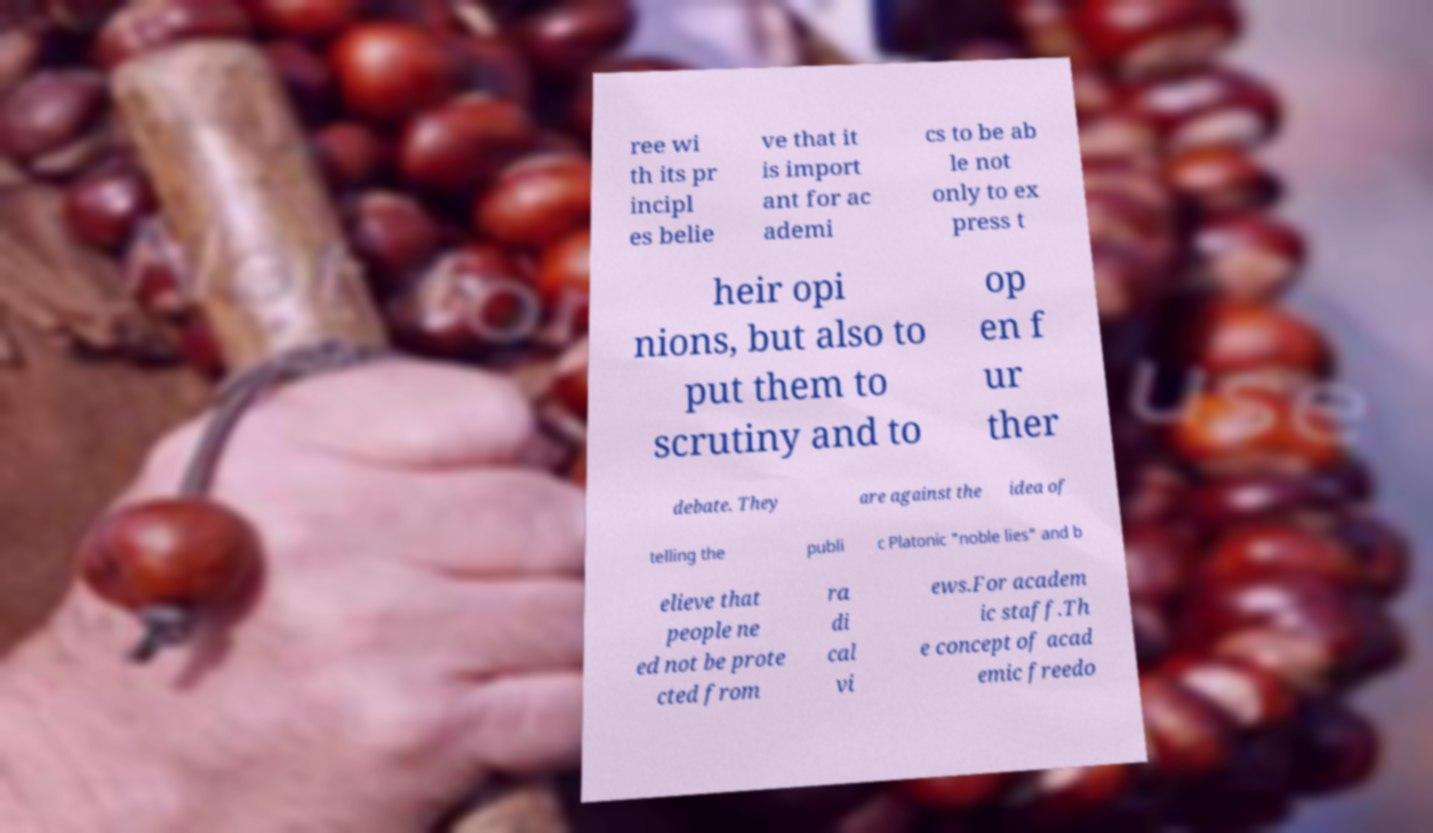Please identify and transcribe the text found in this image. ree wi th its pr incipl es belie ve that it is import ant for ac ademi cs to be ab le not only to ex press t heir opi nions, but also to put them to scrutiny and to op en f ur ther debate. They are against the idea of telling the publi c Platonic "noble lies" and b elieve that people ne ed not be prote cted from ra di cal vi ews.For academ ic staff.Th e concept of acad emic freedo 